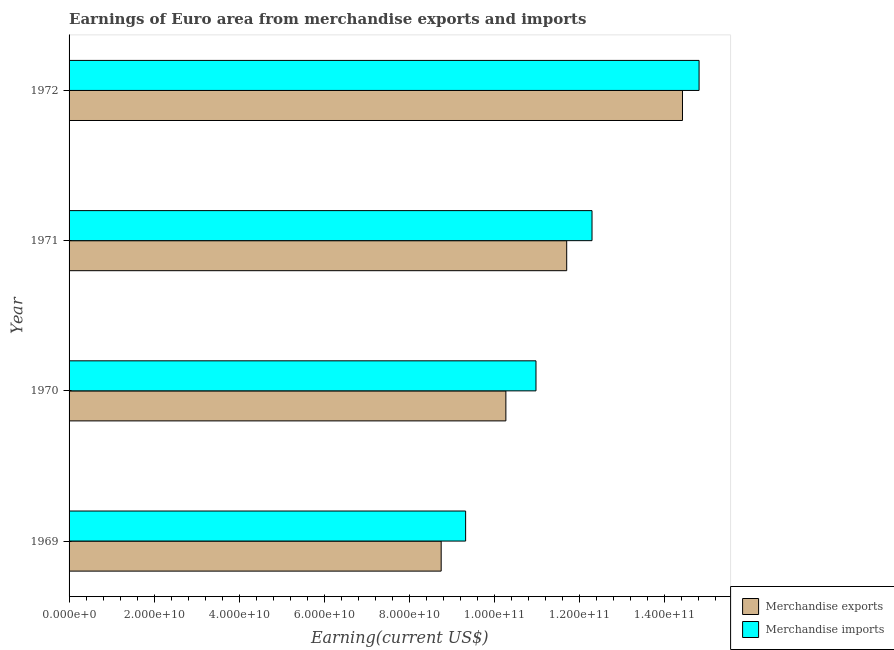Are the number of bars per tick equal to the number of legend labels?
Make the answer very short. Yes. Are the number of bars on each tick of the Y-axis equal?
Offer a terse response. Yes. How many bars are there on the 2nd tick from the top?
Keep it short and to the point. 2. How many bars are there on the 4th tick from the bottom?
Keep it short and to the point. 2. What is the earnings from merchandise exports in 1970?
Keep it short and to the point. 1.03e+11. Across all years, what is the maximum earnings from merchandise exports?
Give a very brief answer. 1.44e+11. Across all years, what is the minimum earnings from merchandise imports?
Give a very brief answer. 9.32e+1. In which year was the earnings from merchandise imports minimum?
Your answer should be compact. 1969. What is the total earnings from merchandise imports in the graph?
Make the answer very short. 4.74e+11. What is the difference between the earnings from merchandise imports in 1970 and that in 1971?
Your response must be concise. -1.32e+1. What is the difference between the earnings from merchandise imports in 1970 and the earnings from merchandise exports in 1969?
Make the answer very short. 2.23e+1. What is the average earnings from merchandise exports per year?
Give a very brief answer. 1.13e+11. In the year 1970, what is the difference between the earnings from merchandise exports and earnings from merchandise imports?
Your answer should be very brief. -7.08e+09. What is the ratio of the earnings from merchandise imports in 1969 to that in 1970?
Provide a short and direct response. 0.85. What is the difference between the highest and the second highest earnings from merchandise exports?
Provide a succinct answer. 2.72e+1. What is the difference between the highest and the lowest earnings from merchandise exports?
Provide a short and direct response. 5.67e+1. In how many years, is the earnings from merchandise imports greater than the average earnings from merchandise imports taken over all years?
Make the answer very short. 2. Is the sum of the earnings from merchandise exports in 1970 and 1971 greater than the maximum earnings from merchandise imports across all years?
Your answer should be very brief. Yes. What does the 1st bar from the top in 1969 represents?
Offer a terse response. Merchandise imports. What does the 1st bar from the bottom in 1969 represents?
Your answer should be very brief. Merchandise exports. How many bars are there?
Your answer should be compact. 8. Are all the bars in the graph horizontal?
Provide a succinct answer. Yes. How many years are there in the graph?
Your response must be concise. 4. What is the difference between two consecutive major ticks on the X-axis?
Offer a very short reply. 2.00e+1. Does the graph contain any zero values?
Ensure brevity in your answer.  No. Does the graph contain grids?
Offer a very short reply. No. What is the title of the graph?
Ensure brevity in your answer.  Earnings of Euro area from merchandise exports and imports. What is the label or title of the X-axis?
Provide a short and direct response. Earning(current US$). What is the label or title of the Y-axis?
Make the answer very short. Year. What is the Earning(current US$) of Merchandise exports in 1969?
Ensure brevity in your answer.  8.75e+1. What is the Earning(current US$) in Merchandise imports in 1969?
Your answer should be very brief. 9.32e+1. What is the Earning(current US$) of Merchandise exports in 1970?
Provide a succinct answer. 1.03e+11. What is the Earning(current US$) in Merchandise imports in 1970?
Offer a terse response. 1.10e+11. What is the Earning(current US$) of Merchandise exports in 1971?
Make the answer very short. 1.17e+11. What is the Earning(current US$) in Merchandise imports in 1971?
Your answer should be very brief. 1.23e+11. What is the Earning(current US$) in Merchandise exports in 1972?
Keep it short and to the point. 1.44e+11. What is the Earning(current US$) of Merchandise imports in 1972?
Offer a very short reply. 1.48e+11. Across all years, what is the maximum Earning(current US$) in Merchandise exports?
Offer a terse response. 1.44e+11. Across all years, what is the maximum Earning(current US$) in Merchandise imports?
Provide a succinct answer. 1.48e+11. Across all years, what is the minimum Earning(current US$) in Merchandise exports?
Your answer should be very brief. 8.75e+1. Across all years, what is the minimum Earning(current US$) in Merchandise imports?
Make the answer very short. 9.32e+1. What is the total Earning(current US$) in Merchandise exports in the graph?
Offer a terse response. 4.51e+11. What is the total Earning(current US$) in Merchandise imports in the graph?
Provide a short and direct response. 4.74e+11. What is the difference between the Earning(current US$) in Merchandise exports in 1969 and that in 1970?
Ensure brevity in your answer.  -1.52e+1. What is the difference between the Earning(current US$) of Merchandise imports in 1969 and that in 1970?
Offer a terse response. -1.65e+1. What is the difference between the Earning(current US$) of Merchandise exports in 1969 and that in 1971?
Provide a succinct answer. -2.95e+1. What is the difference between the Earning(current US$) in Merchandise imports in 1969 and that in 1971?
Provide a succinct answer. -2.97e+1. What is the difference between the Earning(current US$) in Merchandise exports in 1969 and that in 1972?
Offer a terse response. -5.67e+1. What is the difference between the Earning(current US$) of Merchandise imports in 1969 and that in 1972?
Give a very brief answer. -5.49e+1. What is the difference between the Earning(current US$) in Merchandise exports in 1970 and that in 1971?
Provide a short and direct response. -1.43e+1. What is the difference between the Earning(current US$) in Merchandise imports in 1970 and that in 1971?
Your response must be concise. -1.32e+1. What is the difference between the Earning(current US$) of Merchandise exports in 1970 and that in 1972?
Make the answer very short. -4.15e+1. What is the difference between the Earning(current US$) in Merchandise imports in 1970 and that in 1972?
Keep it short and to the point. -3.83e+1. What is the difference between the Earning(current US$) of Merchandise exports in 1971 and that in 1972?
Your answer should be very brief. -2.72e+1. What is the difference between the Earning(current US$) in Merchandise imports in 1971 and that in 1972?
Your answer should be compact. -2.52e+1. What is the difference between the Earning(current US$) in Merchandise exports in 1969 and the Earning(current US$) in Merchandise imports in 1970?
Provide a short and direct response. -2.23e+1. What is the difference between the Earning(current US$) of Merchandise exports in 1969 and the Earning(current US$) of Merchandise imports in 1971?
Make the answer very short. -3.55e+1. What is the difference between the Earning(current US$) of Merchandise exports in 1969 and the Earning(current US$) of Merchandise imports in 1972?
Your answer should be compact. -6.06e+1. What is the difference between the Earning(current US$) in Merchandise exports in 1970 and the Earning(current US$) in Merchandise imports in 1971?
Your response must be concise. -2.02e+1. What is the difference between the Earning(current US$) in Merchandise exports in 1970 and the Earning(current US$) in Merchandise imports in 1972?
Provide a short and direct response. -4.54e+1. What is the difference between the Earning(current US$) in Merchandise exports in 1971 and the Earning(current US$) in Merchandise imports in 1972?
Make the answer very short. -3.11e+1. What is the average Earning(current US$) of Merchandise exports per year?
Ensure brevity in your answer.  1.13e+11. What is the average Earning(current US$) of Merchandise imports per year?
Your response must be concise. 1.18e+11. In the year 1969, what is the difference between the Earning(current US$) in Merchandise exports and Earning(current US$) in Merchandise imports?
Provide a succinct answer. -5.75e+09. In the year 1970, what is the difference between the Earning(current US$) in Merchandise exports and Earning(current US$) in Merchandise imports?
Your answer should be compact. -7.08e+09. In the year 1971, what is the difference between the Earning(current US$) in Merchandise exports and Earning(current US$) in Merchandise imports?
Your answer should be very brief. -5.95e+09. In the year 1972, what is the difference between the Earning(current US$) of Merchandise exports and Earning(current US$) of Merchandise imports?
Your response must be concise. -3.90e+09. What is the ratio of the Earning(current US$) in Merchandise exports in 1969 to that in 1970?
Give a very brief answer. 0.85. What is the ratio of the Earning(current US$) of Merchandise imports in 1969 to that in 1970?
Offer a terse response. 0.85. What is the ratio of the Earning(current US$) in Merchandise exports in 1969 to that in 1971?
Provide a short and direct response. 0.75. What is the ratio of the Earning(current US$) of Merchandise imports in 1969 to that in 1971?
Make the answer very short. 0.76. What is the ratio of the Earning(current US$) of Merchandise exports in 1969 to that in 1972?
Your answer should be compact. 0.61. What is the ratio of the Earning(current US$) in Merchandise imports in 1969 to that in 1972?
Your answer should be compact. 0.63. What is the ratio of the Earning(current US$) of Merchandise exports in 1970 to that in 1971?
Ensure brevity in your answer.  0.88. What is the ratio of the Earning(current US$) of Merchandise imports in 1970 to that in 1971?
Offer a terse response. 0.89. What is the ratio of the Earning(current US$) in Merchandise exports in 1970 to that in 1972?
Provide a succinct answer. 0.71. What is the ratio of the Earning(current US$) of Merchandise imports in 1970 to that in 1972?
Your answer should be very brief. 0.74. What is the ratio of the Earning(current US$) in Merchandise exports in 1971 to that in 1972?
Keep it short and to the point. 0.81. What is the ratio of the Earning(current US$) of Merchandise imports in 1971 to that in 1972?
Make the answer very short. 0.83. What is the difference between the highest and the second highest Earning(current US$) of Merchandise exports?
Provide a succinct answer. 2.72e+1. What is the difference between the highest and the second highest Earning(current US$) in Merchandise imports?
Make the answer very short. 2.52e+1. What is the difference between the highest and the lowest Earning(current US$) in Merchandise exports?
Provide a short and direct response. 5.67e+1. What is the difference between the highest and the lowest Earning(current US$) in Merchandise imports?
Offer a very short reply. 5.49e+1. 